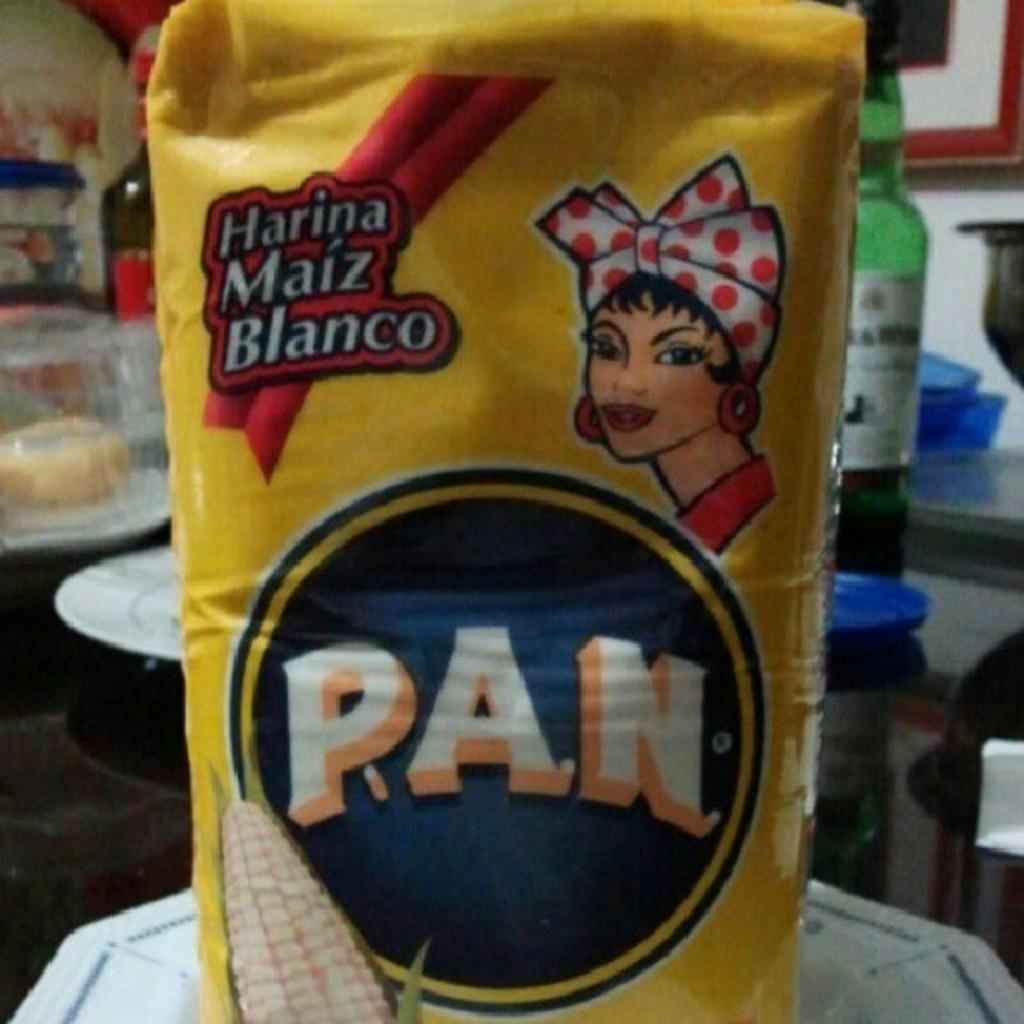Provide a one-sentence caption for the provided image. A yellow bag of P.A.N. corn flower sits on a white plate. 